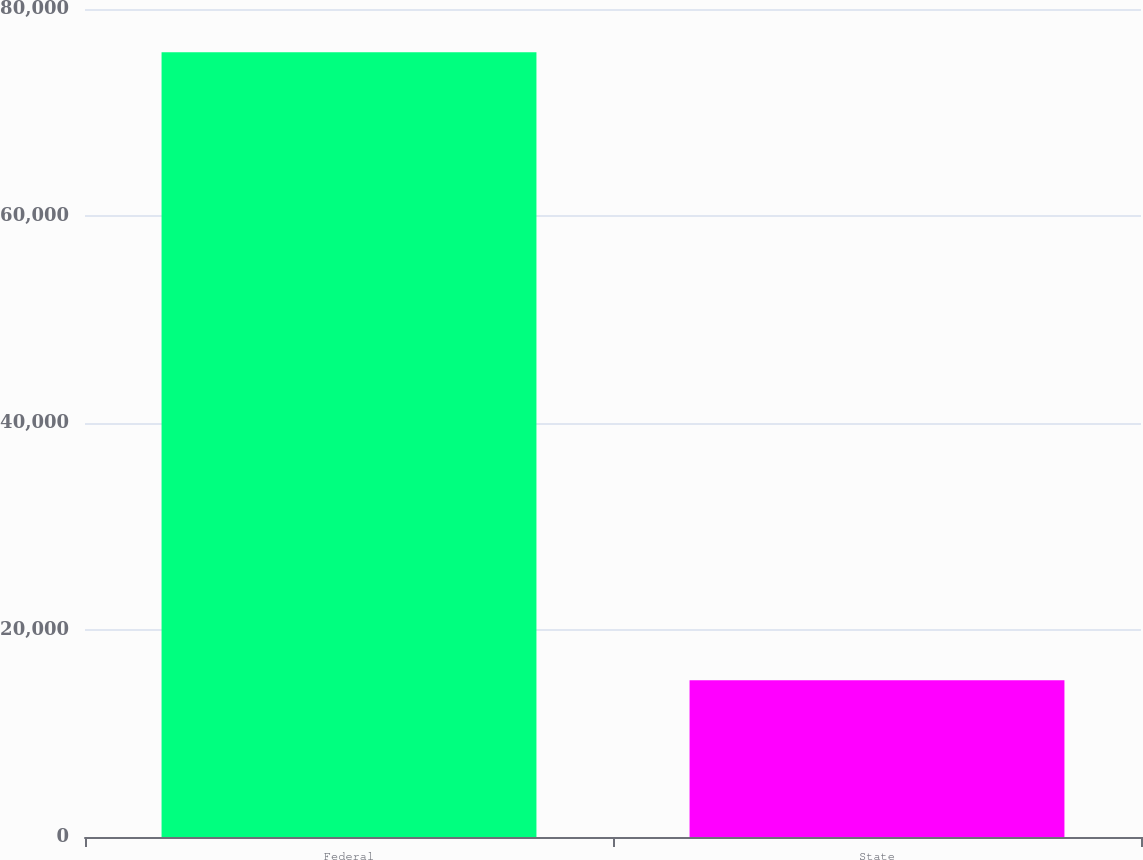<chart> <loc_0><loc_0><loc_500><loc_500><bar_chart><fcel>Federal<fcel>State<nl><fcel>75817<fcel>15151<nl></chart> 